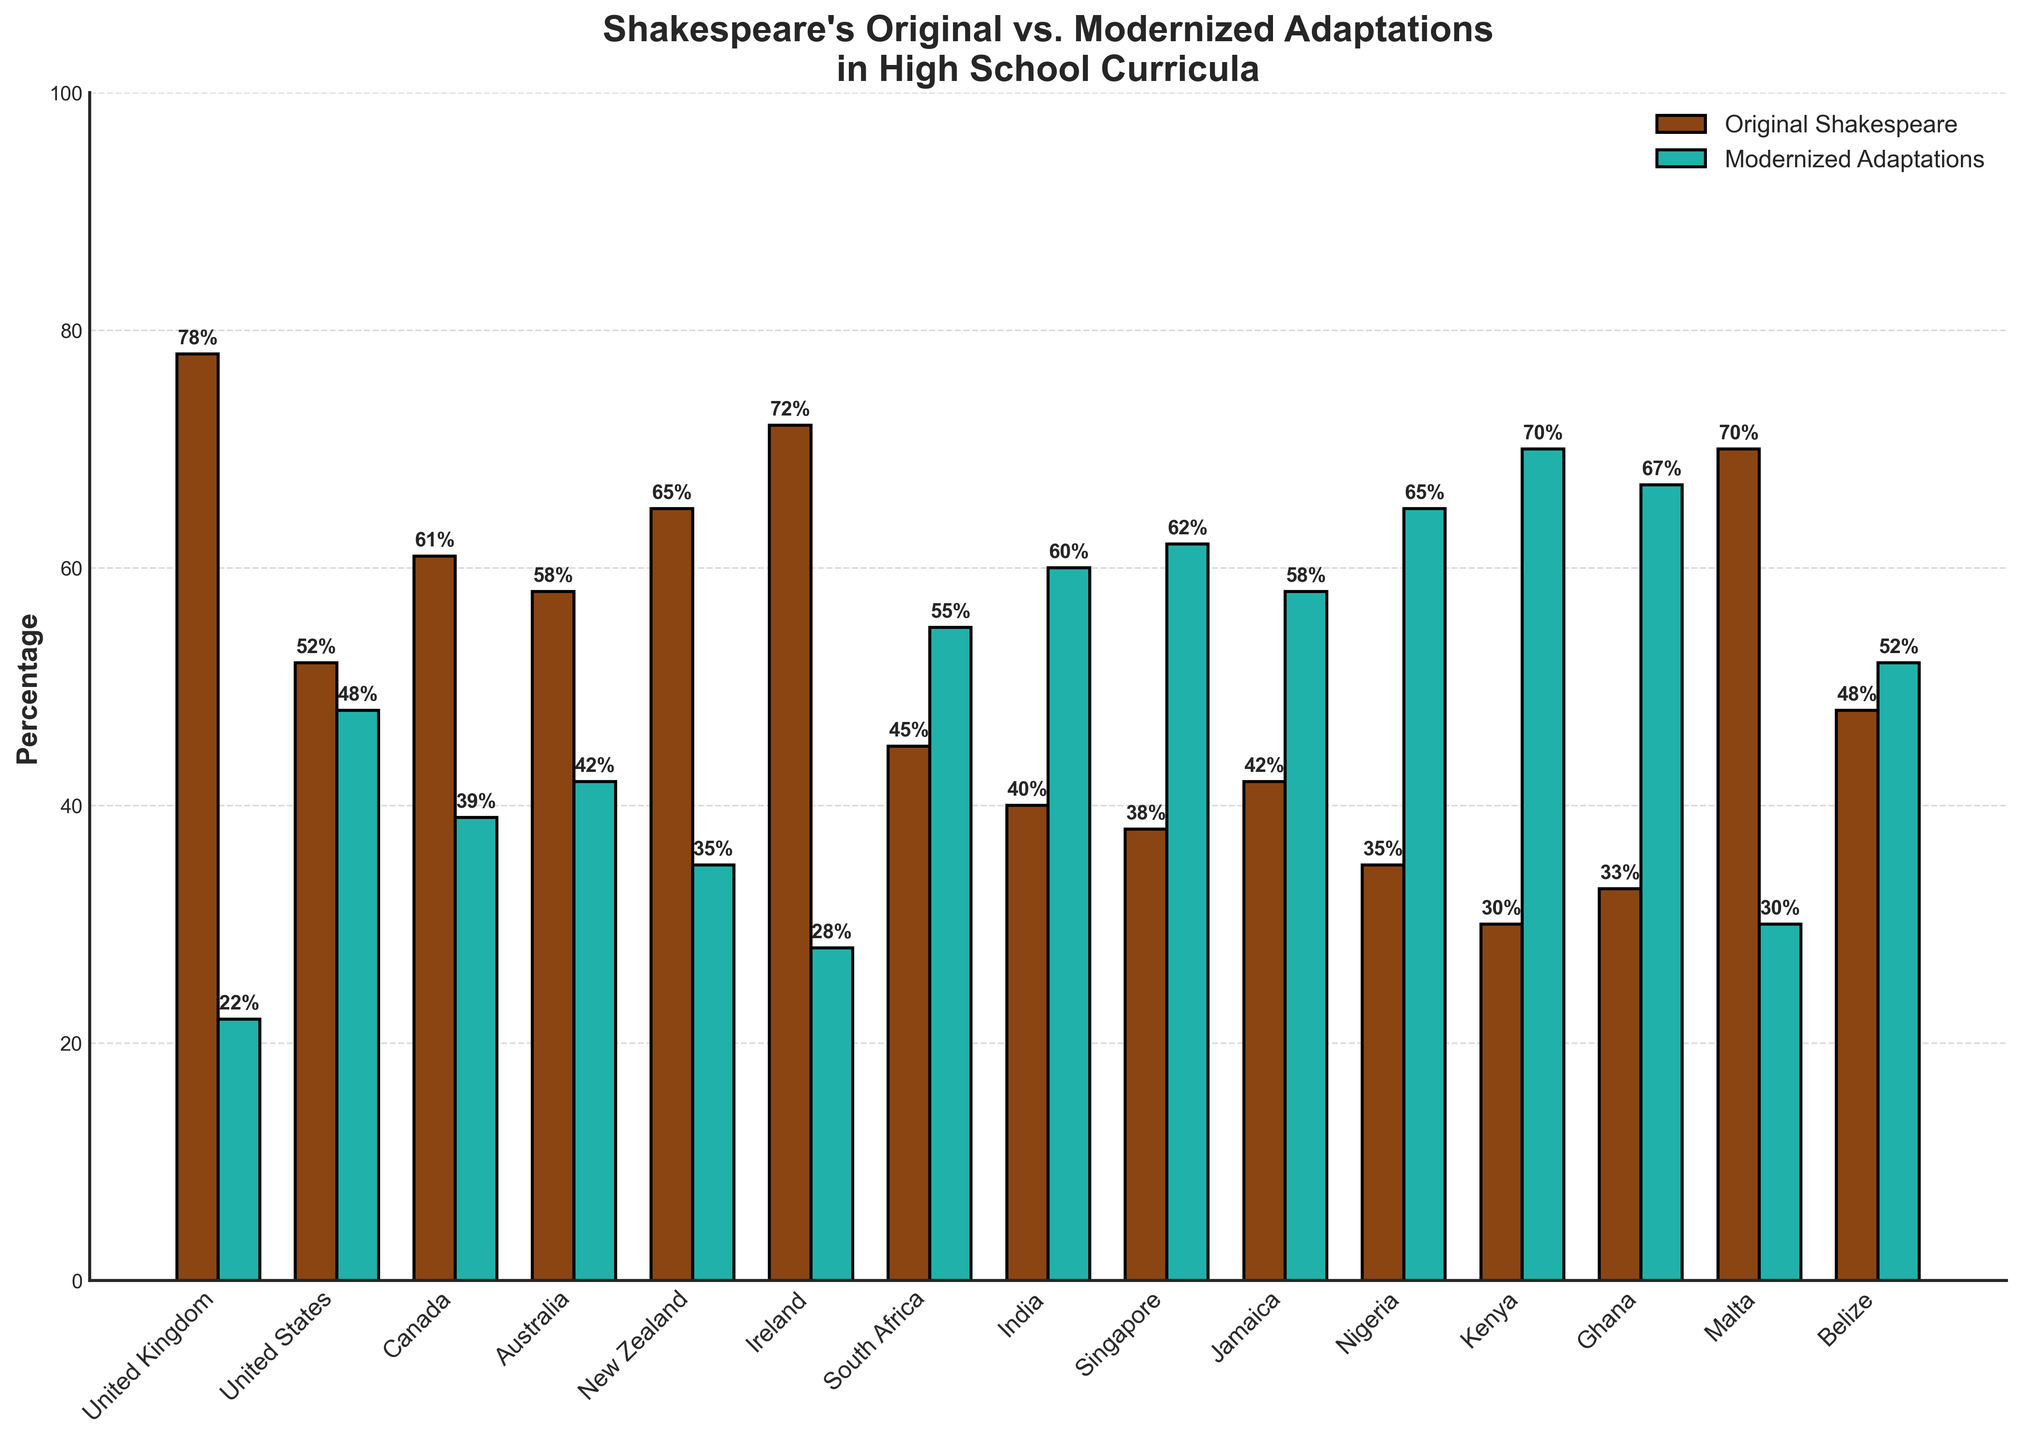What is the percentage difference in the usage of Original Shakespearean texts between the United Kingdom and Nigeria? The percentage of Original Shakespearean texts in the United Kingdom is 78%, and in Nigeria, it is 35%. The difference is 78 - 35 = 43%.
Answer: 43% Which country uses Modernized Adaptations the most in their high school curriculum? By observing the heights of the bars, Kenya uses the highest percentage of Modernized Adaptations at 70%.
Answer: Kenya Compare the combined percentage of Original Shakespearean texts in Jamaica and Singapore to that in Ireland. Which is higher and by how much? Jamaica has 42% and Singapore has 38%. Their combined percentage is 42 + 38 = 80%. Ireland has 72%. The combined percentage of Jamaica and Singapore is higher by 80 - 72 = 8%.
Answer: Jamaica and Singapore by 8% Which country has an equal split between Original Shakespearean texts and Modernized Adaptations? By identifying the bars with equal heights, Belize shows a 48% usage of Original Shakespeare and a 52% usage of Modernized Adaptations, which are almost equal, but no country has exactly equal.
Answer: None exactly equal (Belize is closest) What is the average percentage of Original Shakespearean texts in the countries where over 60% of the curriculum uses Original texts? These countries are the United Kingdom (78%), Canada (61%), New Zealand (65%), Ireland (72%), and Malta (70%). The average is (78 + 61 + 65 + 72 + 70) / 5 = 346 / 5 = 69.2%.
Answer: 69.2% Between Australia and New Zealand, which country utilizes more Modernized Adaptations, and by what percentage? Australia uses 42% Modernized Adaptations, while New Zealand uses 35%. Australia uses more Modernized Adaptations by 42 - 35 = 7%.
Answer: Australia by 7% How many countries have at least 50% of their curriculum based on Modernized Adaptations? Observing the heights of the bars, the United States (48%), South Africa (55%), India (60%), Singapore (62%), Jamaica (58%), Nigeria (65%), Kenya (70%), and Ghana (67%) have at least 50% usage of Modernized Adaptations. There are 7 such countries.
Answer: 7 What is the visual difference in the usage of Original Shakespearean texts between Malta and Singapore? Malta has a significantly higher bar at 70% compared to Singapore’s much lower bar at 38%. The visual difference is quite prominent.
Answer: Malta significantly higher than Singapore Which country has the closest percentage of Original Shakespearean texts to 50%, and what is that percentage? The country closest to 50% is the United States with 52%.
Answer: United States, 52% 